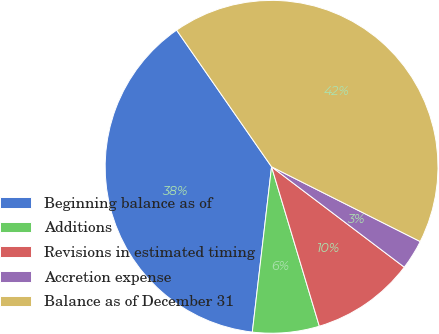Convert chart to OTSL. <chart><loc_0><loc_0><loc_500><loc_500><pie_chart><fcel>Beginning balance as of<fcel>Additions<fcel>Revisions in estimated timing<fcel>Accretion expense<fcel>Balance as of December 31<nl><fcel>38.49%<fcel>6.48%<fcel>10.06%<fcel>2.89%<fcel>42.08%<nl></chart> 